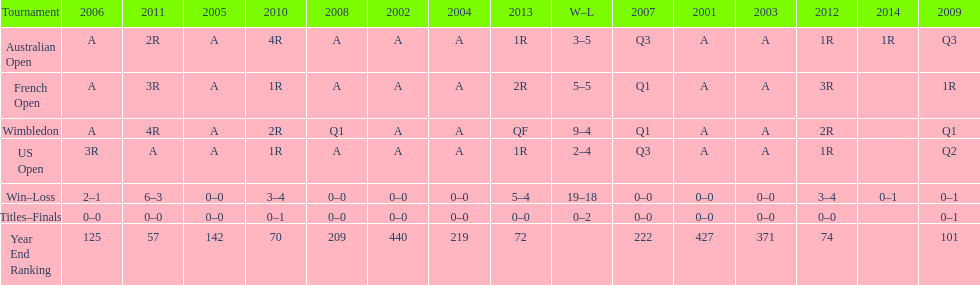What tournament has 5-5 as it's "w-l" record? French Open. 